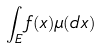Convert formula to latex. <formula><loc_0><loc_0><loc_500><loc_500>\int _ { E } f ( x ) \mu ( d x )</formula> 